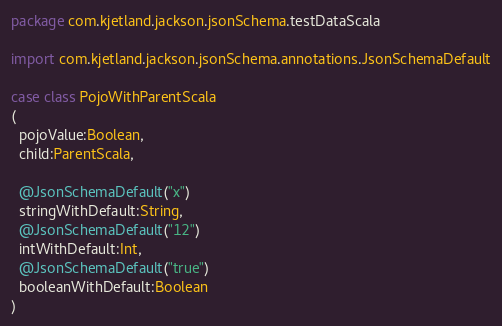Convert code to text. <code><loc_0><loc_0><loc_500><loc_500><_Scala_>package com.kjetland.jackson.jsonSchema.testDataScala

import com.kjetland.jackson.jsonSchema.annotations.JsonSchemaDefault

case class PojoWithParentScala
(
  pojoValue:Boolean,
  child:ParentScala,

  @JsonSchemaDefault("x")
  stringWithDefault:String,
  @JsonSchemaDefault("12")
  intWithDefault:Int,
  @JsonSchemaDefault("true")
  booleanWithDefault:Boolean
)
</code> 